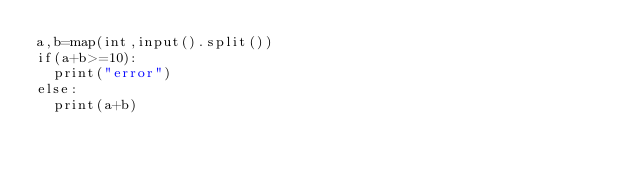Convert code to text. <code><loc_0><loc_0><loc_500><loc_500><_Python_>a,b=map(int,input().split())
if(a+b>=10):
  print("error")
else:
  print(a+b)
</code> 